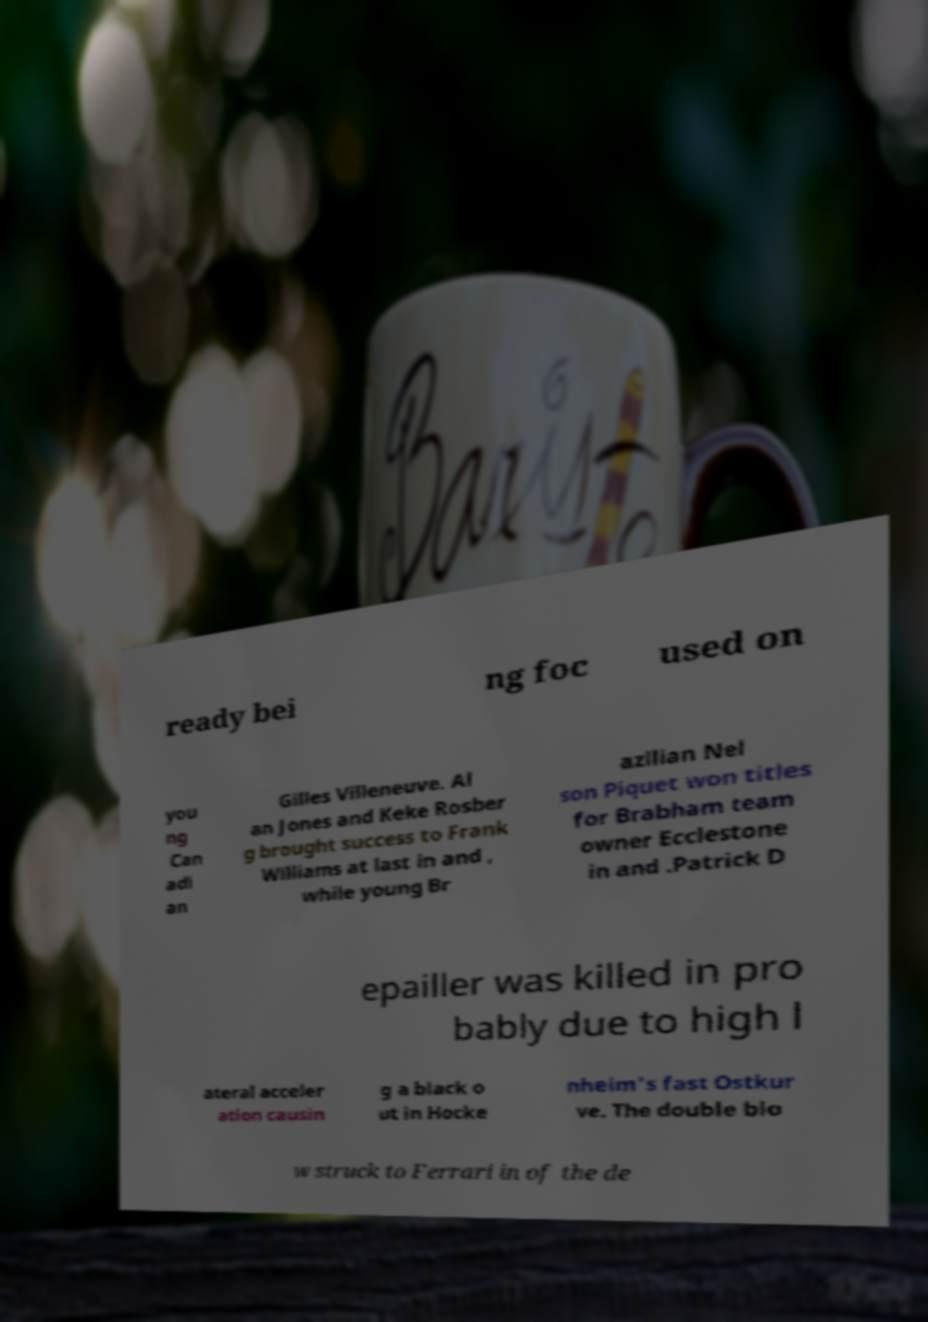There's text embedded in this image that I need extracted. Can you transcribe it verbatim? ready bei ng foc used on you ng Can adi an Gilles Villeneuve. Al an Jones and Keke Rosber g brought success to Frank Williams at last in and , while young Br azilian Nel son Piquet won titles for Brabham team owner Ecclestone in and .Patrick D epailler was killed in pro bably due to high l ateral acceler ation causin g a black o ut in Hocke nheim's fast Ostkur ve. The double blo w struck to Ferrari in of the de 